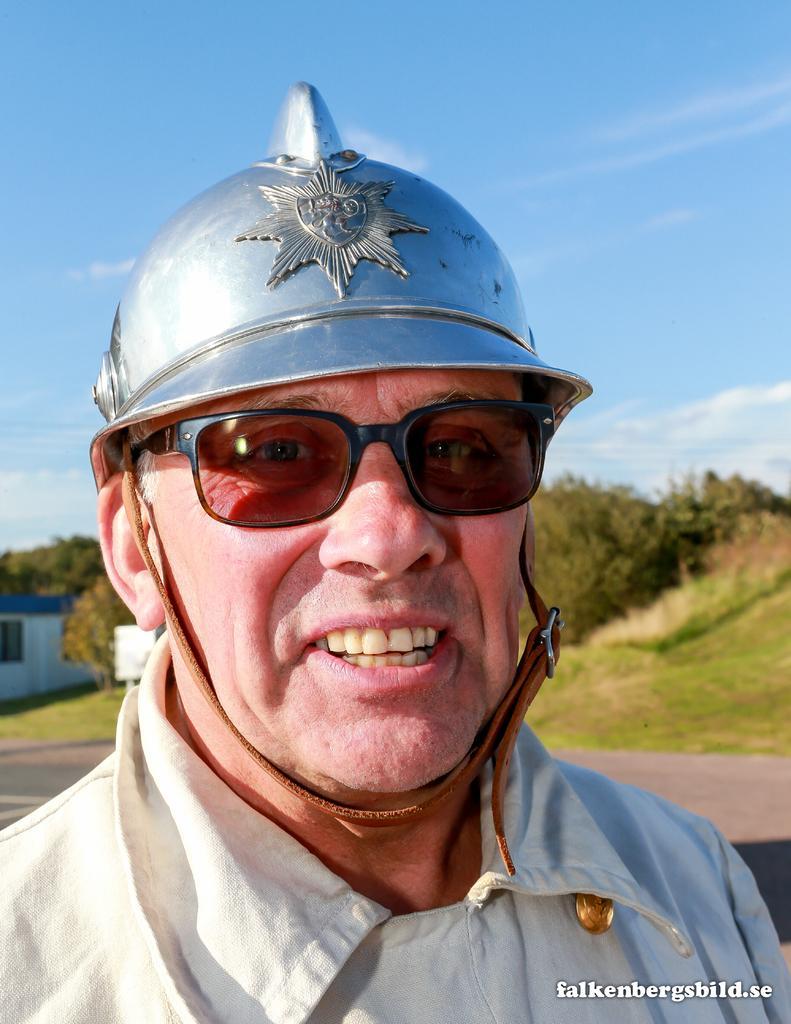Please provide a concise description of this image. In the center of the image, we can see a person wearing glasses and a cap. In the background, there are trees and we can see a shed. At the bottom, there is road and we can see some text. At the top, there is sky. 